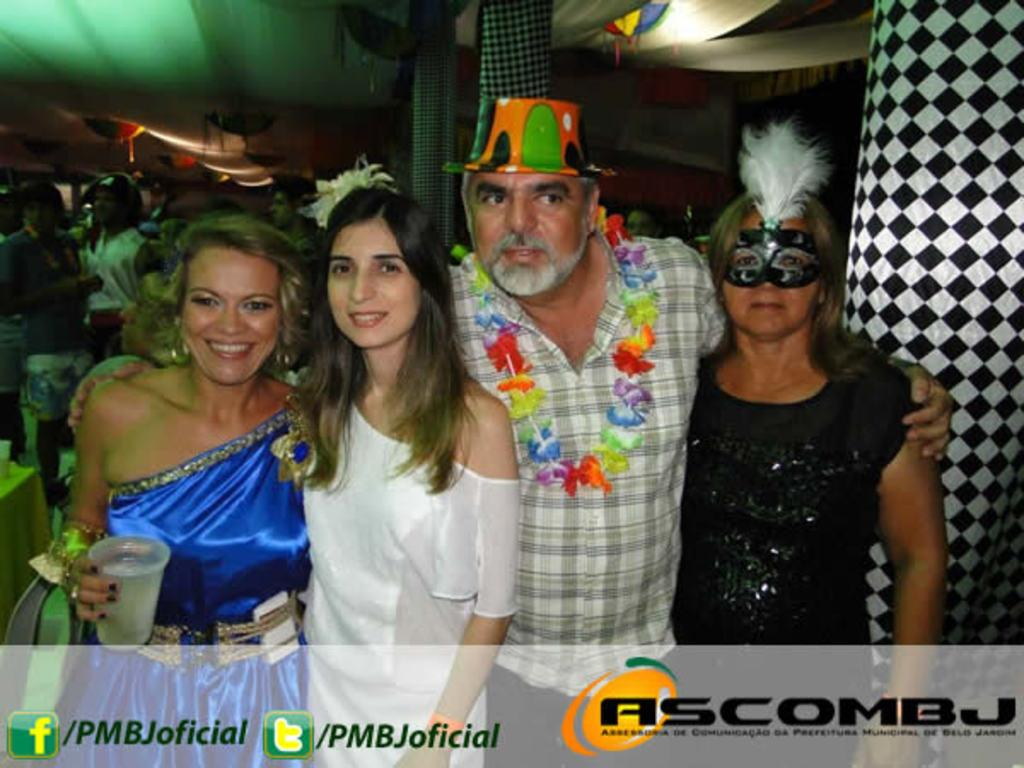What is one object visible in the image? There is a glass in the image. What is another object visible in the image? There is a cap in the image. What is a third object visible in the image? There is a mask in the image. What type of decoration can be seen in the image? There is a garland in the image. What architectural feature is present in the image? There are pillars in the image. How many people are standing and smiling in the image? There are four people standing and smiling in the image. Can you describe the people visible at the back of the four people? There is a group of people visible at the back of the four people. What type of lighting is present in the image? There are lights in the image. What other items can be seen in the image? There are some objects visible in the image. Where are the scissors located in the image? There are no scissors present in the image. What type of harbor can be seen in the image? There is no harbor present in the image. 